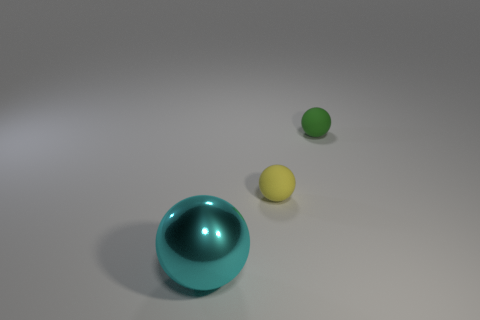Subtract all large metal spheres. How many spheres are left? 2 Add 3 cyan things. How many objects exist? 6 Subtract all green balls. How many balls are left? 2 Subtract 0 purple cylinders. How many objects are left? 3 Subtract all red balls. Subtract all red cylinders. How many balls are left? 3 Subtract all blue cylinders. How many gray spheres are left? 0 Subtract all large gray matte cylinders. Subtract all small green balls. How many objects are left? 2 Add 3 big cyan spheres. How many big cyan spheres are left? 4 Add 1 big cyan metallic spheres. How many big cyan metallic spheres exist? 2 